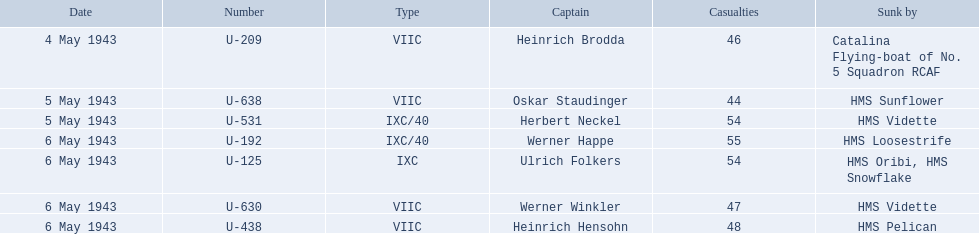Who are the commanders of the u-boats? Heinrich Brodda, Oskar Staudinger, Herbert Neckel, Werner Happe, Ulrich Folkers, Werner Winkler, Heinrich Hensohn. What are the dates the u-boat commanders were lost? 4 May 1943, 5 May 1943, 5 May 1943, 6 May 1943, 6 May 1943, 6 May 1943, 6 May 1943. Of these, which were lost on may 5? Oskar Staudinger, Herbert Neckel. Apart from oskar staudinger, who else was lost on this day? Herbert Neckel. 